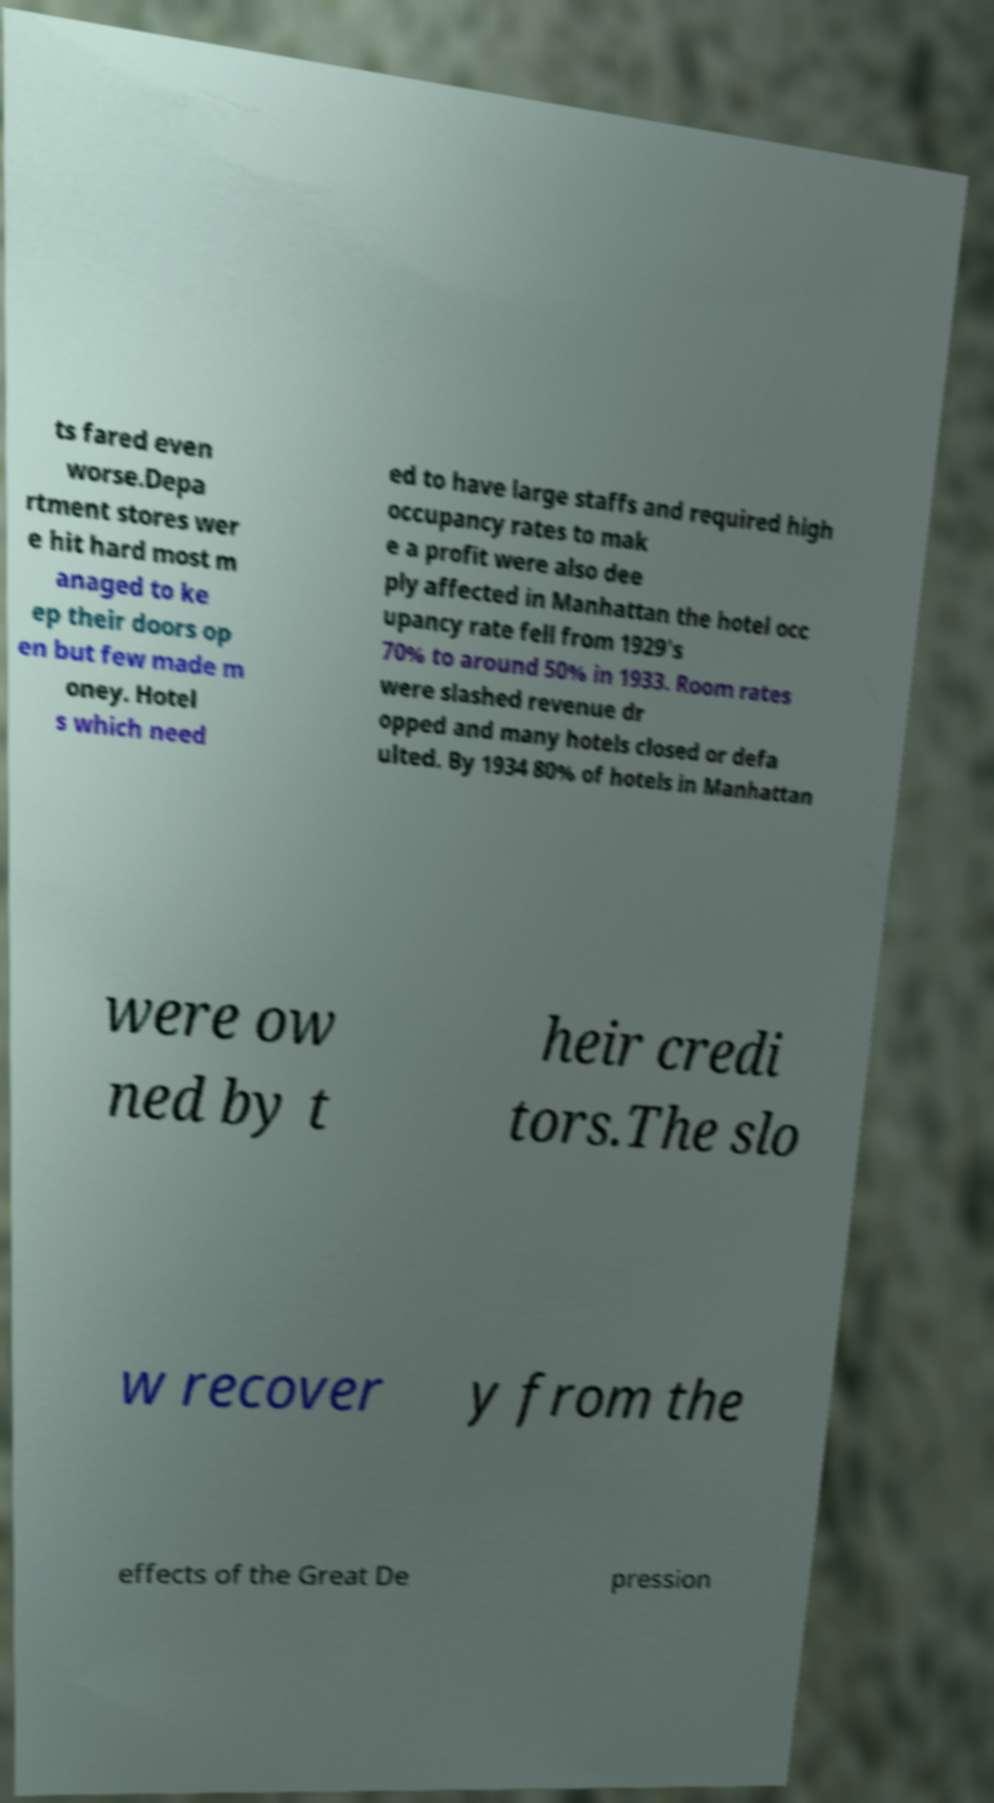There's text embedded in this image that I need extracted. Can you transcribe it verbatim? ts fared even worse.Depa rtment stores wer e hit hard most m anaged to ke ep their doors op en but few made m oney. Hotel s which need ed to have large staffs and required high occupancy rates to mak e a profit were also dee ply affected in Manhattan the hotel occ upancy rate fell from 1929's 70% to around 50% in 1933. Room rates were slashed revenue dr opped and many hotels closed or defa ulted. By 1934 80% of hotels in Manhattan were ow ned by t heir credi tors.The slo w recover y from the effects of the Great De pression 